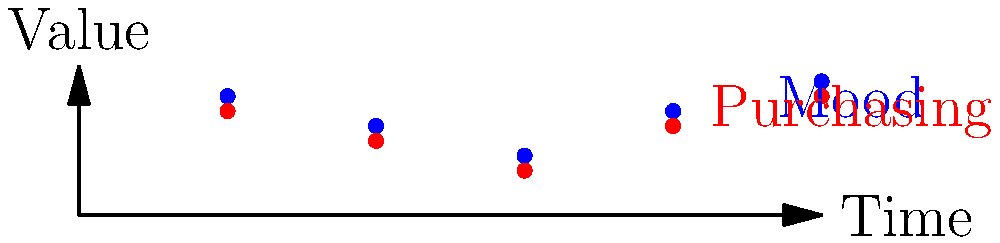Given the mood vector $\mathbf{m} = [0.8, 0.6, 0.4, 0.7, 0.9]$ and purchasing behavior vector $\mathbf{p} = [0.7, 0.5, 0.3, 0.6, 0.8]$ over five time periods, calculate the cosine similarity between these two vectors using the dot product. What does this result indicate about the relationship between mood and purchasing behavior? To calculate the cosine similarity using the dot product, we follow these steps:

1. Calculate the dot product of $\mathbf{m}$ and $\mathbf{p}$:
   $$\mathbf{m} \cdot \mathbf{p} = (0.8 \times 0.7) + (0.6 \times 0.5) + (0.4 \times 0.3) + (0.7 \times 0.6) + (0.9 \times 0.8) = 2.11$$

2. Calculate the magnitude of $\mathbf{m}$:
   $$|\mathbf{m}| = \sqrt{0.8^2 + 0.6^2 + 0.4^2 + 0.7^2 + 0.9^2} = 1.5297$$

3. Calculate the magnitude of $\mathbf{p}$:
   $$|\mathbf{p}| = \sqrt{0.7^2 + 0.5^2 + 0.3^2 + 0.6^2 + 0.8^2} = 1.3784$$

4. Calculate the cosine similarity:
   $$\cos \theta = \frac{\mathbf{m} \cdot \mathbf{p}}{|\mathbf{m}||\mathbf{p}|} = \frac{2.11}{1.5297 \times 1.3784} = 0.9997$$

The cosine similarity of 0.9997 indicates a very strong positive correlation between mood and purchasing behavior. This suggests that as mood increases, purchasing behavior tends to increase as well, and vice versa.
Answer: 0.9997; strong positive correlation 